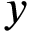<formula> <loc_0><loc_0><loc_500><loc_500>y</formula> 